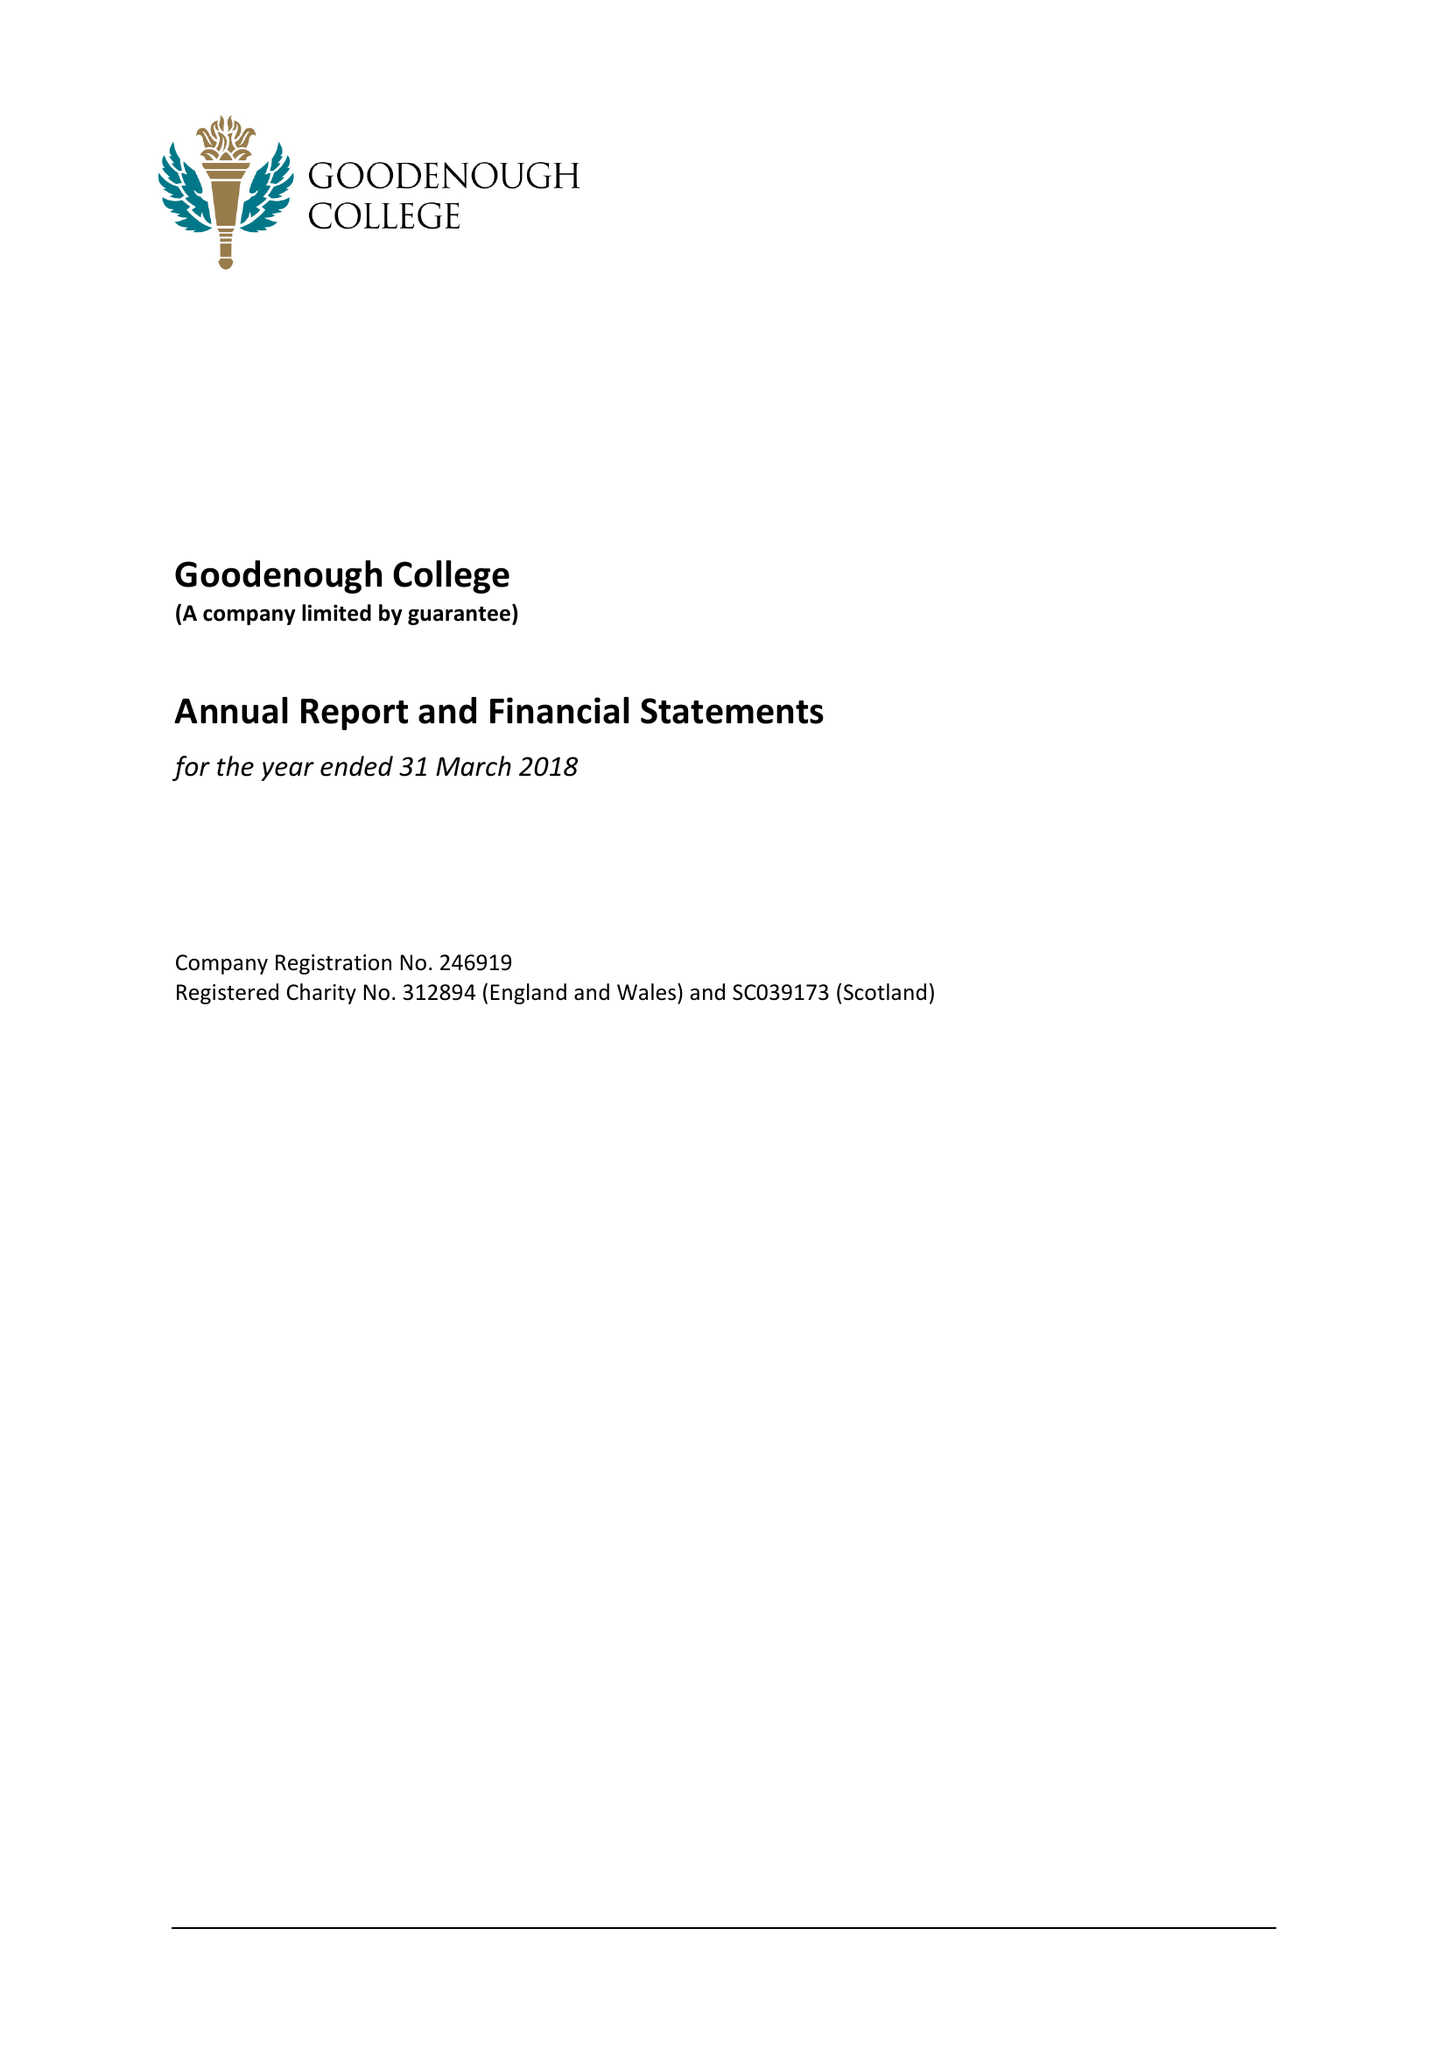What is the value for the spending_annually_in_british_pounds?
Answer the question using a single word or phrase. 13621000.00 